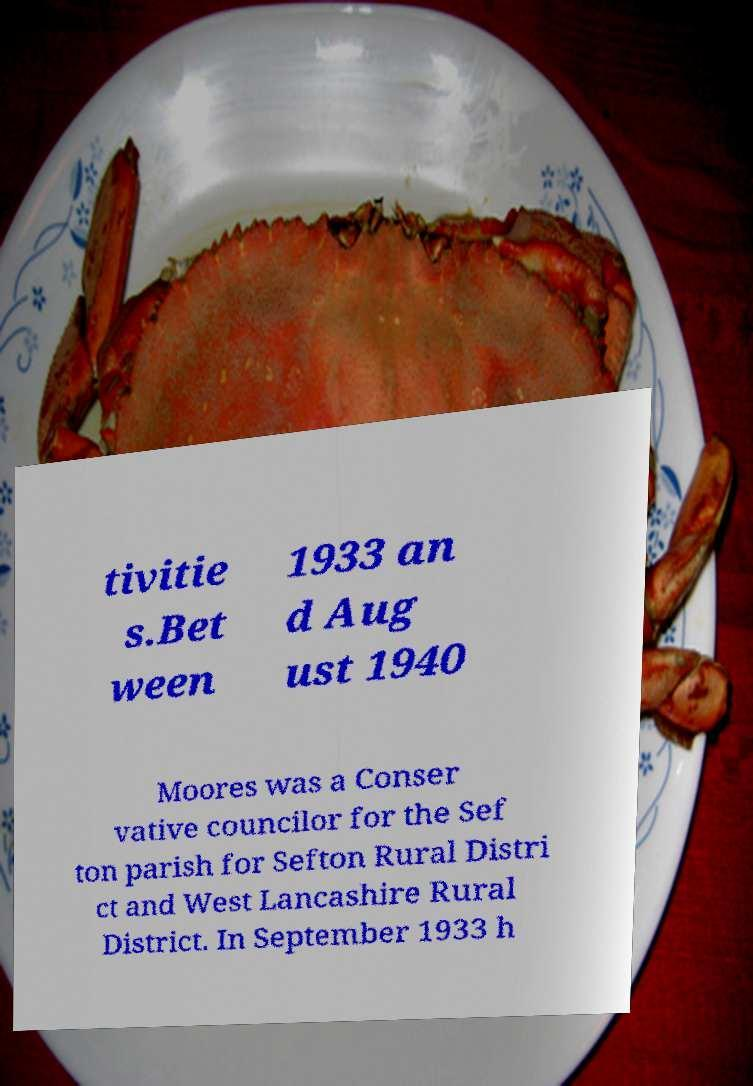I need the written content from this picture converted into text. Can you do that? tivitie s.Bet ween 1933 an d Aug ust 1940 Moores was a Conser vative councilor for the Sef ton parish for Sefton Rural Distri ct and West Lancashire Rural District. In September 1933 h 